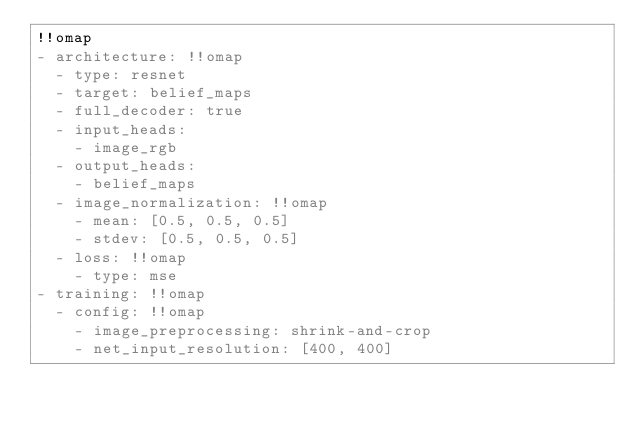Convert code to text. <code><loc_0><loc_0><loc_500><loc_500><_YAML_>!!omap
- architecture: !!omap
  - type: resnet
  - target: belief_maps
  - full_decoder: true
  - input_heads:
    - image_rgb
  - output_heads:
    - belief_maps
  - image_normalization: !!omap
    - mean: [0.5, 0.5, 0.5]
    - stdev: [0.5, 0.5, 0.5]
  - loss: !!omap
    - type: mse
- training: !!omap
  - config: !!omap
    - image_preprocessing: shrink-and-crop
    - net_input_resolution: [400, 400]
</code> 